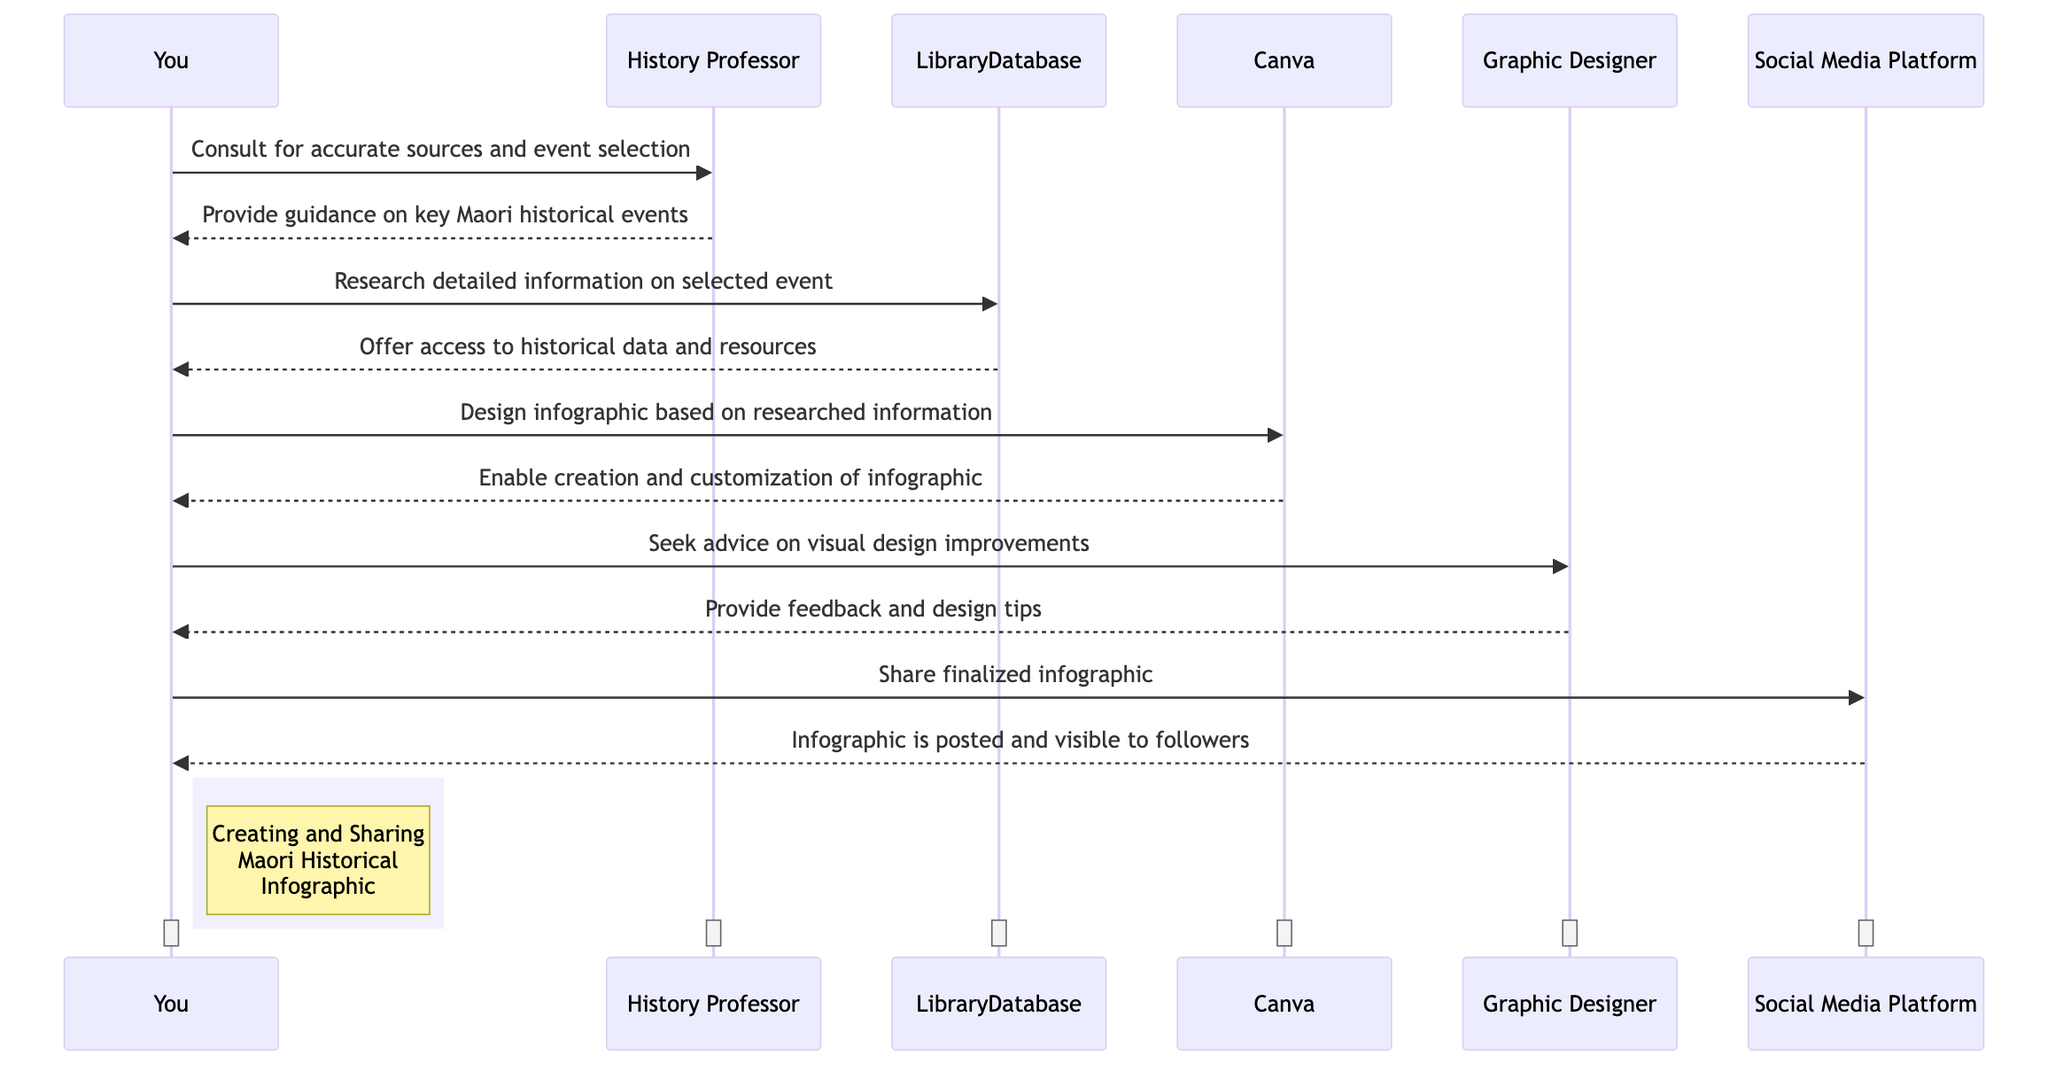What is the first action the student takes? The student first consults the history professor to get accurate sources and to select a key Maori historical event. This is depicted at the beginning of the sequence diagram where an arrow points from the student to the history professor.
Answer: Consult for accurate sources and event selection How many main actors are involved in the sequence? The sequence diagram lists four main actors, which are the student, history professor, graphic designer, and social media platform. Each actor is identified clearly in the diagram.
Answer: Four What is the role of Canva in this process? Canva is identified as the infographic design tool in the sequence. The student interacts with Canva to design the infographic based on the researched information. This is shown in the middle of the sequence.
Answer: Infographic Design Tool Who provides guidance on key Maori historical events? The history professor provides guidance on key Maori historical events to the student. This is marked in the sequence with a message flowing back from the professor to the student.
Answer: History Professor What step follows after the student researches in the library database? After the student researches and accesses historical data and resources from the library database, the next step is for the student to design the infographic using Canva. The diagram demonstrates this sequential flow with an arrow from the student to Canva.
Answer: Design infographic based on researched information What feedback does the student seek after designing the infographic? The student seeks advice on visual design improvements from the graphic designer after creating the infographic. This inquiry is indicated by the message from the student to the graphic designer in the sequence.
Answer: Seek advice on visual design improvements What is the final action taken by the student in the sequence? The final action taken by the student is to share the finalized infographic on the social media platform. This is represented at the end of the sequence diagram with an arrow from the student to the social media platform.
Answer: Share finalized infographic How many messages are exchanged between the student and the graphic designer? There are two messages exchanged: the student seeks advice from the graphic designer, and in return, the graphic designer provides feedback and design tips. This can be counted in the sequence as two arrows between these two parties.
Answer: Two Which object offers access to historical data and resources? The library database is the object that offers access to historical data and resources when the student makes a request. This interaction is visually represented in the sequence by an arrow flowing from the library database to the student.
Answer: LibraryDatabase 